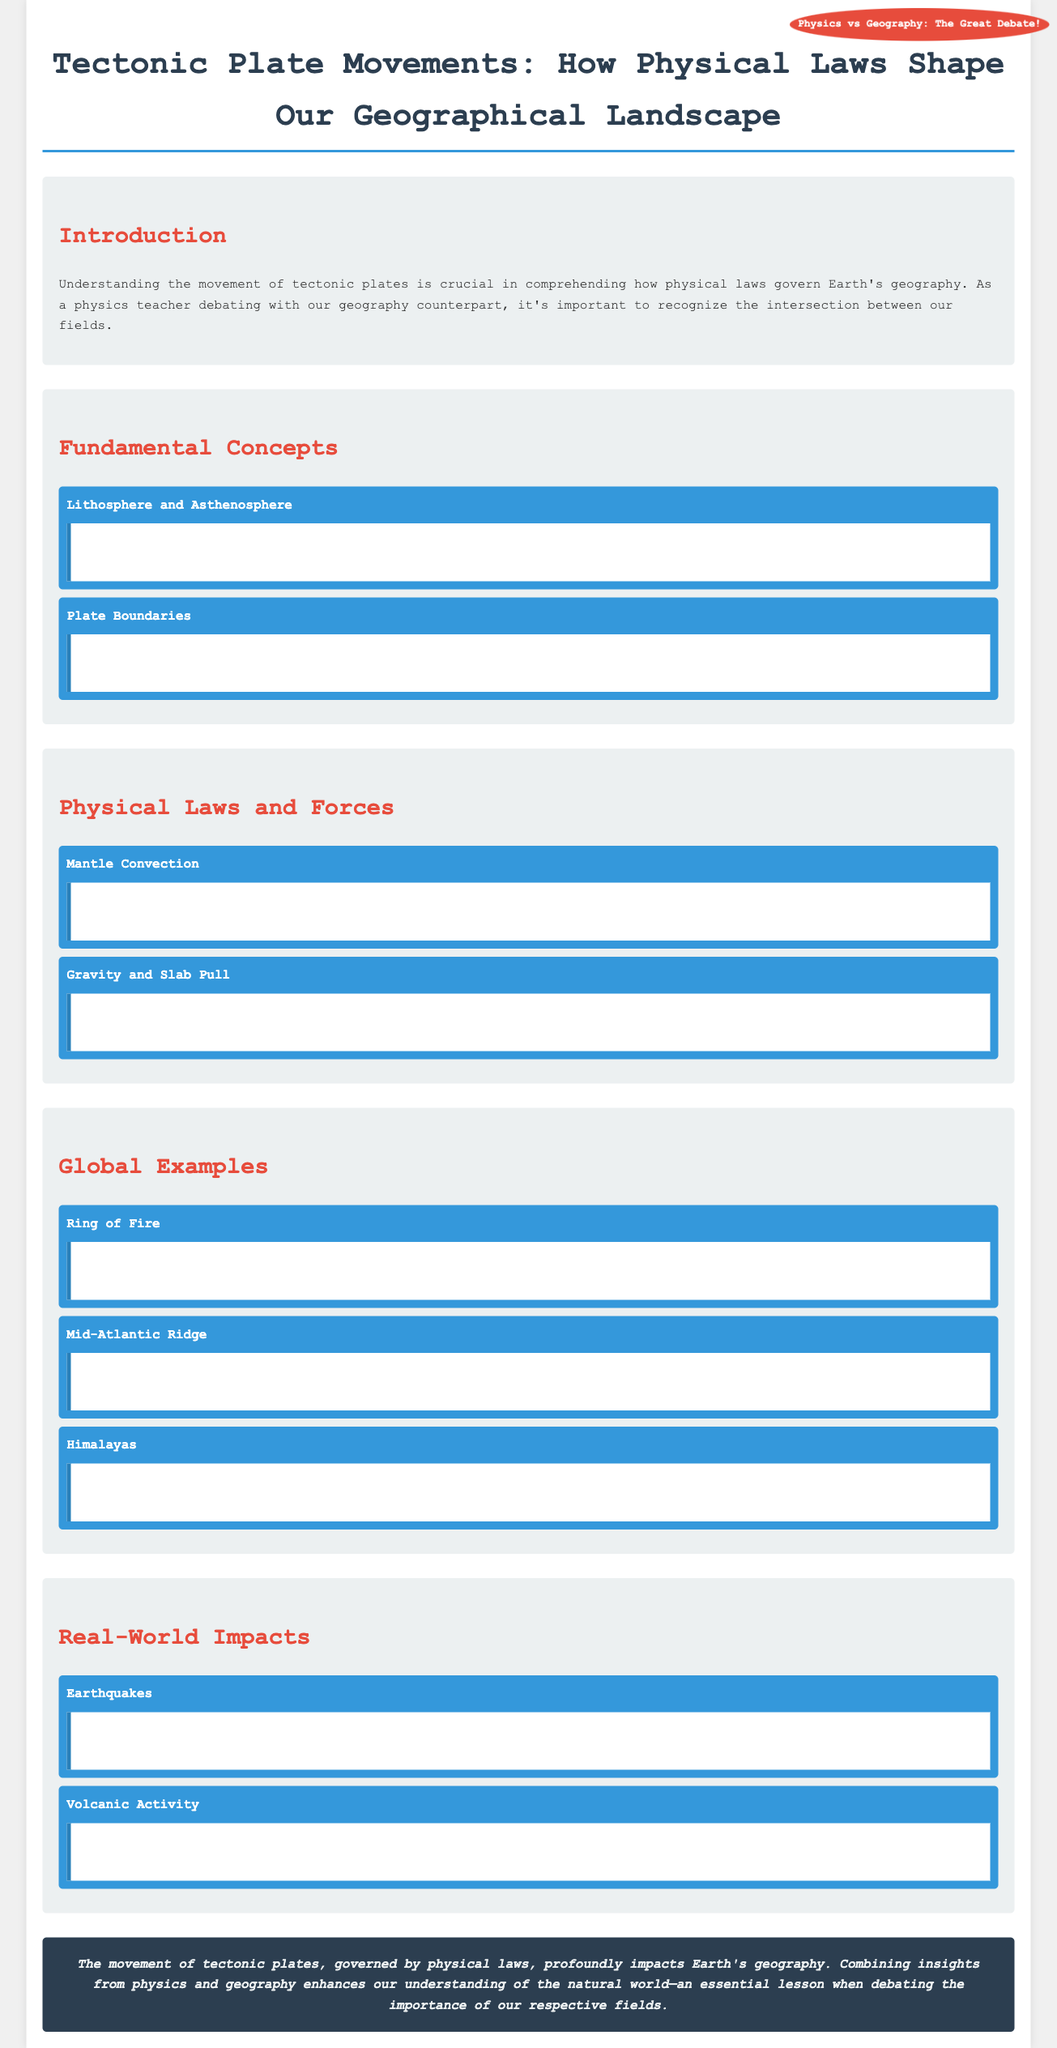What is the rigid outer layer of Earth called? The document states that the lithosphere is the rigid outer layer of Earth.
Answer: lithosphere What are the three types of plate boundaries? The document categorizes plate boundaries into three types: divergent, convergent, and transform.
Answer: divergent, convergent, transform What drives plate movements through the transfer of heat and matter? The document explains that mantle convection drives plate movements through the transfer of heat and matter.
Answer: mantle convection Which region is known for earthquakes and volcanic activity? The document identifies the Ring of Fire as a major area known for earthquakes and volcanic activity.
Answer: Ring of Fire What forms the Himalayas? The document states that the Himalayas are formed by the collision between the Indian Plate and the Eurasian Plate.
Answer: collision between the Indian Plate and the Eurasian Plate How do gravity and slab pull assist plate movement? The document mentions that gravity assists plate movement through ridge push and slab pull.
Answer: ridge push and slab pull What happens during sudden movements at fault lines? The document explains that sudden movements at fault lines cause ground shaking and potential damage.
Answer: ground shaking and potential damage What creates volcanic eruptions at plate boundaries? The document states that magma from beneath the Earth's crust reaching the surface creates volcanic eruptions.
Answer: magma reaches the surface How does understanding tectonic plate movements benefit science? The document suggests that combining insights from physics and geography enhances our understanding of the natural world.
Answer: enhances our understanding of the natural world 